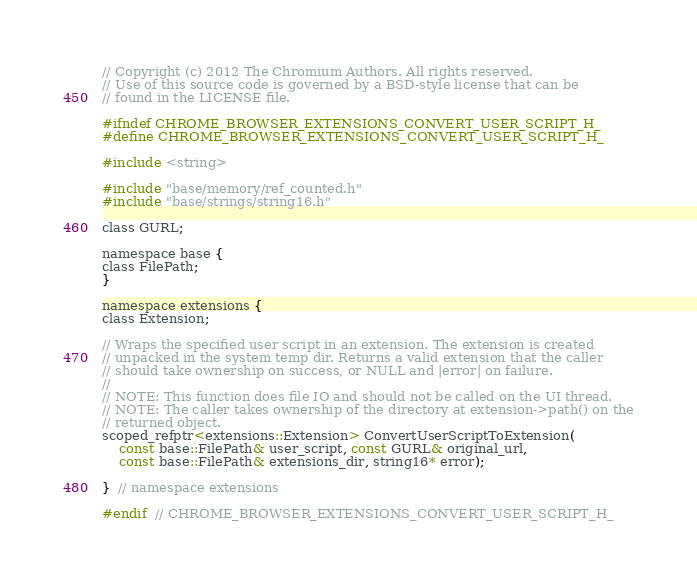<code> <loc_0><loc_0><loc_500><loc_500><_C_>// Copyright (c) 2012 The Chromium Authors. All rights reserved.
// Use of this source code is governed by a BSD-style license that can be
// found in the LICENSE file.

#ifndef CHROME_BROWSER_EXTENSIONS_CONVERT_USER_SCRIPT_H_
#define CHROME_BROWSER_EXTENSIONS_CONVERT_USER_SCRIPT_H_

#include <string>

#include "base/memory/ref_counted.h"
#include "base/strings/string16.h"

class GURL;

namespace base {
class FilePath;
}

namespace extensions {
class Extension;

// Wraps the specified user script in an extension. The extension is created
// unpacked in the system temp dir. Returns a valid extension that the caller
// should take ownership on success, or NULL and |error| on failure.
//
// NOTE: This function does file IO and should not be called on the UI thread.
// NOTE: The caller takes ownership of the directory at extension->path() on the
// returned object.
scoped_refptr<extensions::Extension> ConvertUserScriptToExtension(
    const base::FilePath& user_script, const GURL& original_url,
    const base::FilePath& extensions_dir, string16* error);

}  // namespace extensions

#endif  // CHROME_BROWSER_EXTENSIONS_CONVERT_USER_SCRIPT_H_
</code> 